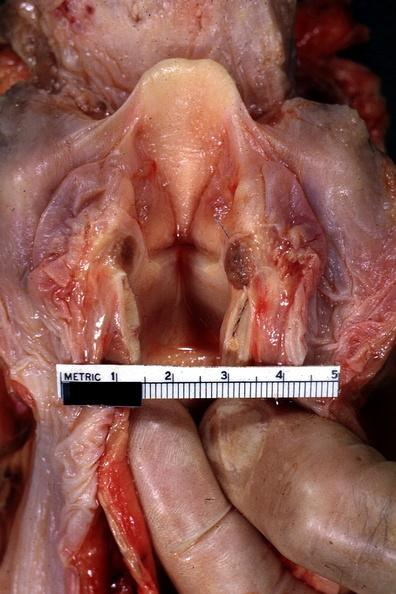what is present?
Answer the question using a single word or phrase. Edema hypopharynx 